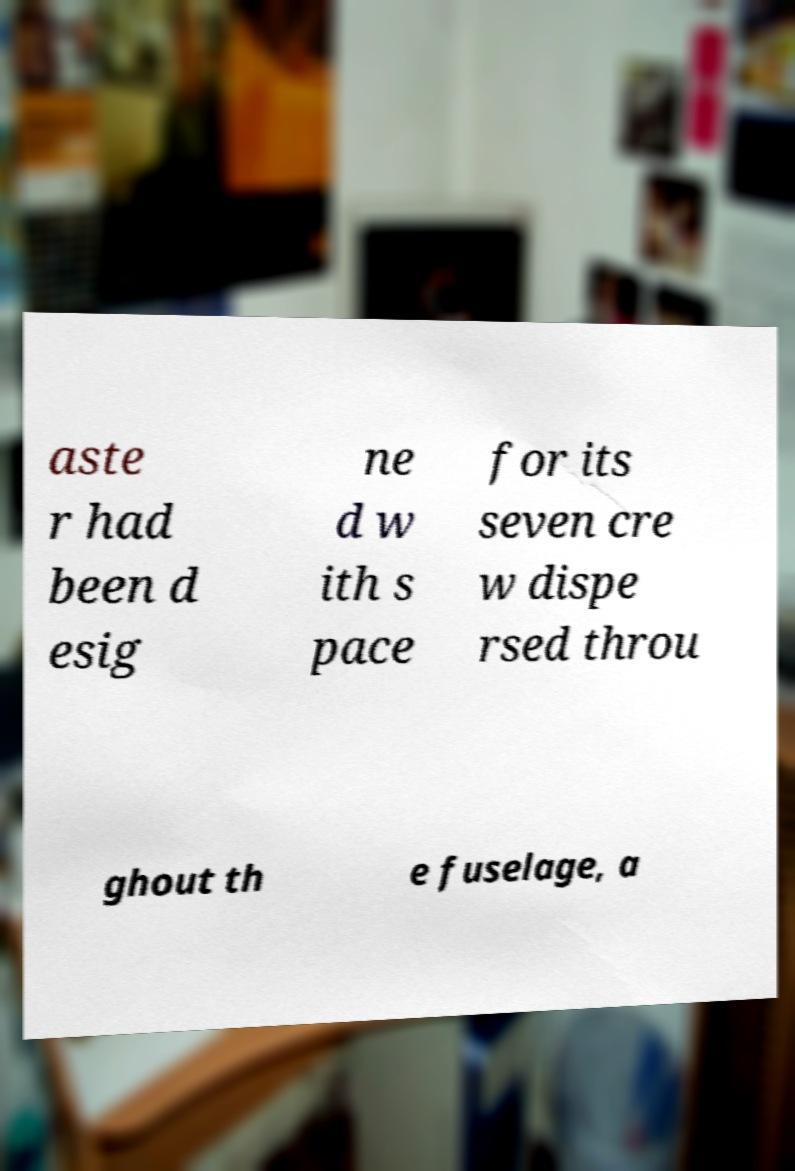Can you read and provide the text displayed in the image?This photo seems to have some interesting text. Can you extract and type it out for me? aste r had been d esig ne d w ith s pace for its seven cre w dispe rsed throu ghout th e fuselage, a 